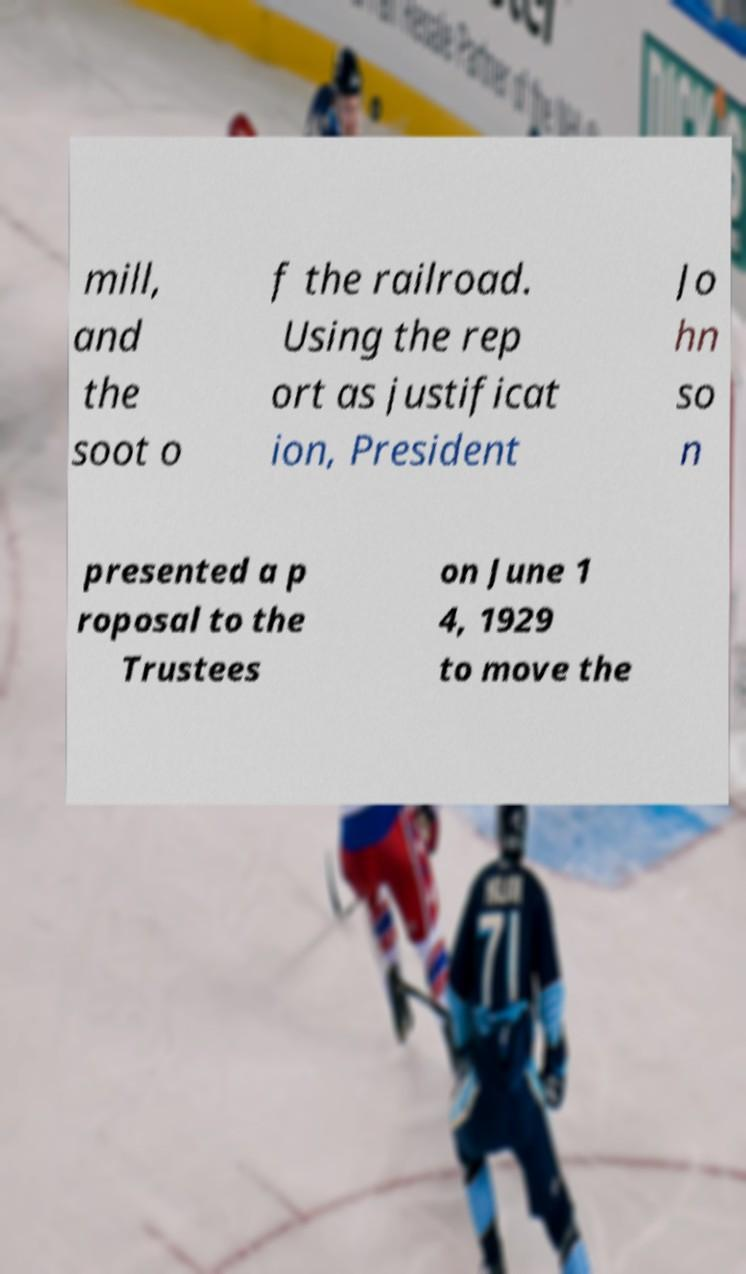For documentation purposes, I need the text within this image transcribed. Could you provide that? mill, and the soot o f the railroad. Using the rep ort as justificat ion, President Jo hn so n presented a p roposal to the Trustees on June 1 4, 1929 to move the 